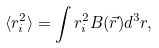Convert formula to latex. <formula><loc_0><loc_0><loc_500><loc_500>\langle r _ { i } ^ { 2 } \rangle = \int r _ { i } ^ { 2 } B ( \vec { r } ) d ^ { 3 } r ,</formula> 